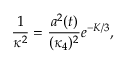<formula> <loc_0><loc_0><loc_500><loc_500>\frac { 1 } { \kappa ^ { 2 } } = \frac { a ^ { 2 } ( t ) } { ( \kappa _ { 4 } ) ^ { 2 } } e ^ { - K / 3 } ,</formula> 